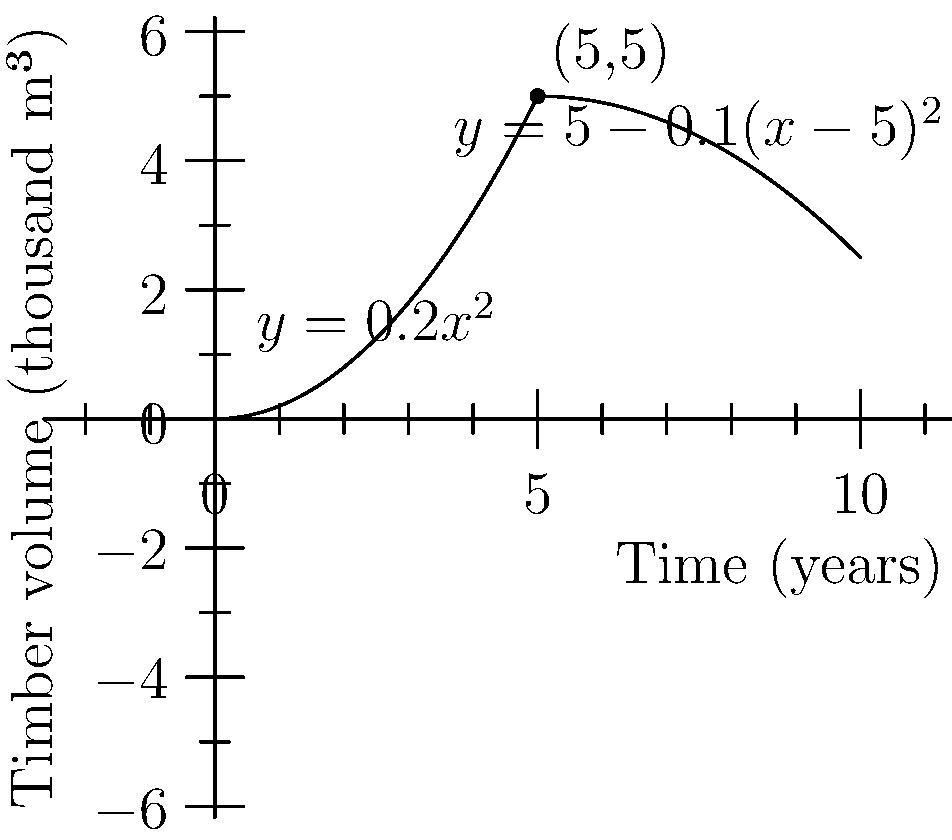The graph represents the volume of timber in a forest over time, where $y$ is the timber volume in thousand cubic meters and $x$ is the time in years. The function is piecewise, defined as:

$$f(x) = \begin{cases} 
0.2x^2 & \text{if } x < 5 \\
5 - 0.1(x-5)^2 & \text{if } x \geq 5
\end{cases}$$

To maximize sustainable timber yield, you need to harvest when the rate of change of timber volume is highest. At what time should you harvest the timber? To find the optimal harvesting time, we need to determine when the rate of change (derivative) of the timber volume is at its maximum. Let's approach this step-by-step:

1) First, we need to find the derivative of each piece of the function:
   For $x < 5$: $f'(x) = 0.4x$
   For $x \geq 5$: $f'(x) = -0.2(x-5)$

2) The rate of change is increasing in the first piece and decreasing in the second piece. The maximum rate of change will occur at the transition point between the two pieces, which is at $x = 5$.

3) To verify, let's calculate the limit of the derivative as we approach 5 from both sides:
   Left limit: $\lim_{x \to 5^-} f'(x) = 0.4(5) = 2$
   Right limit: $\lim_{x \to 5^+} f'(x) = -0.2(5-5) = 0$

4) The left limit is greater than the right limit, confirming that the maximum rate of change occurs just before $x = 5$.

5) Therefore, the optimal time to harvest is at 5 years, just before the growth rate starts to decrease.

This harvesting strategy aligns with sustainable forestry practices, as it allows for maximum timber yield while ensuring the forest has time to regrow before the next harvest cycle.
Answer: 5 years 